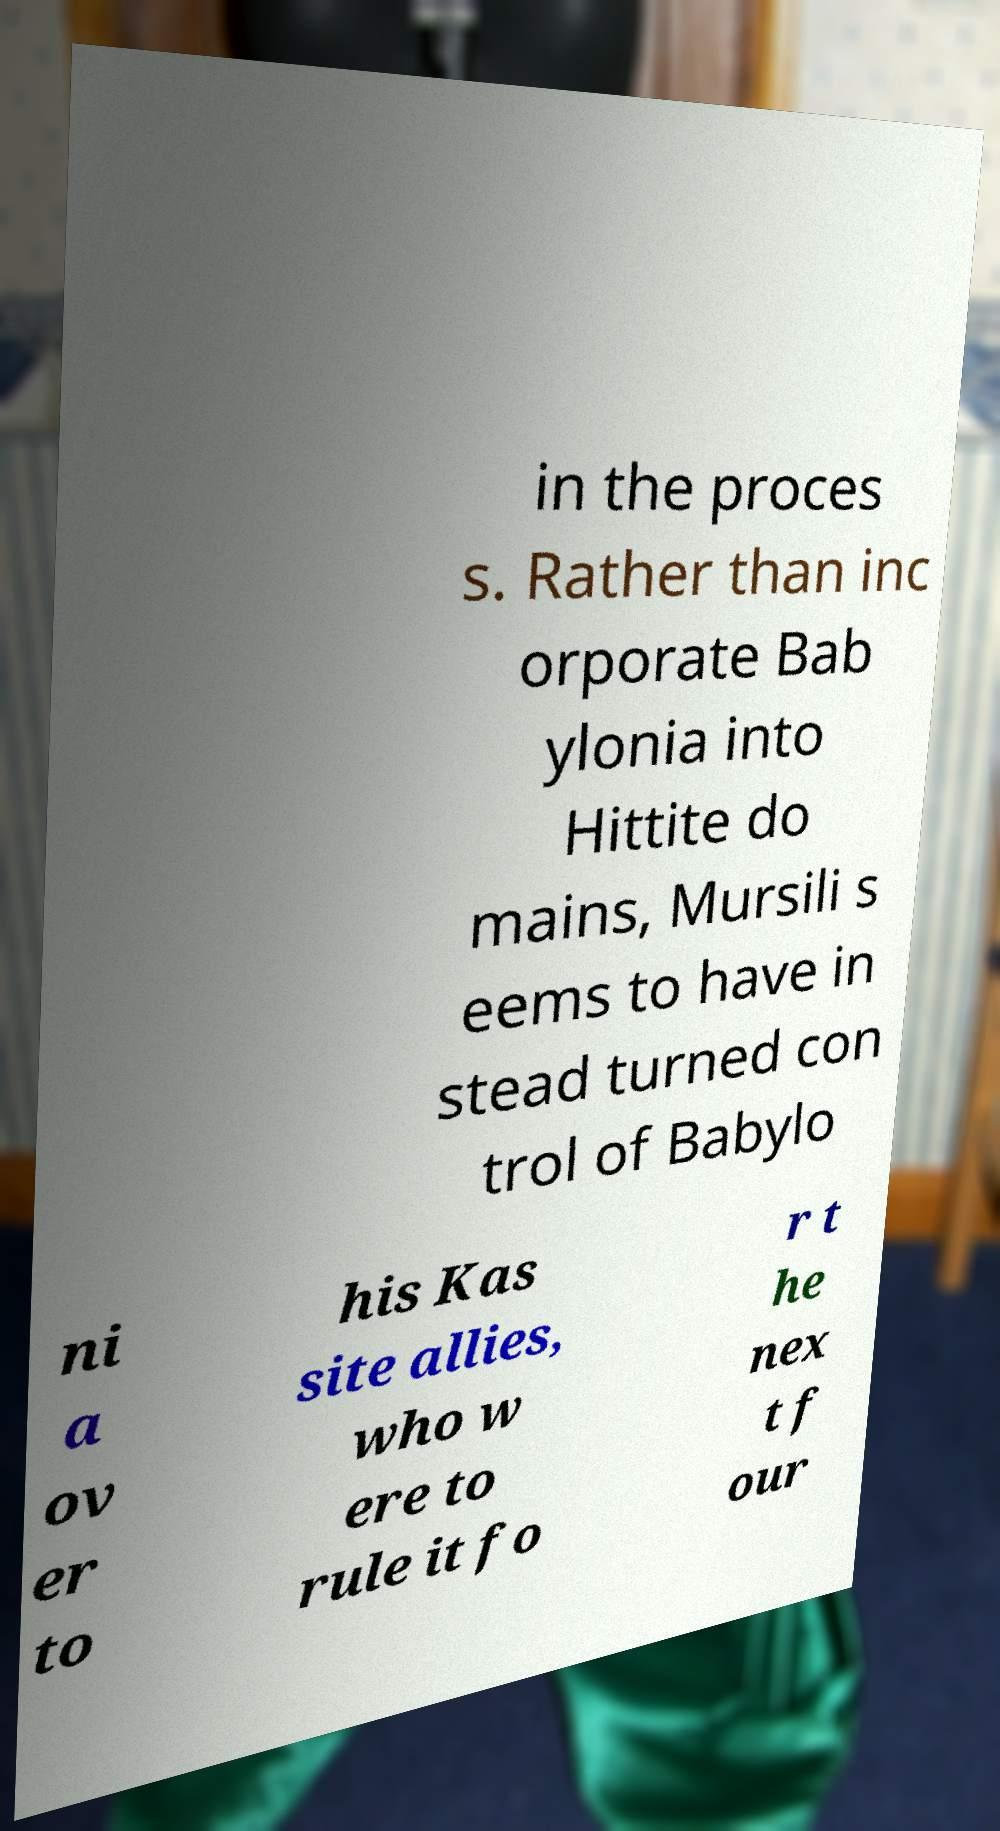For documentation purposes, I need the text within this image transcribed. Could you provide that? in the proces s. Rather than inc orporate Bab ylonia into Hittite do mains, Mursili s eems to have in stead turned con trol of Babylo ni a ov er to his Kas site allies, who w ere to rule it fo r t he nex t f our 